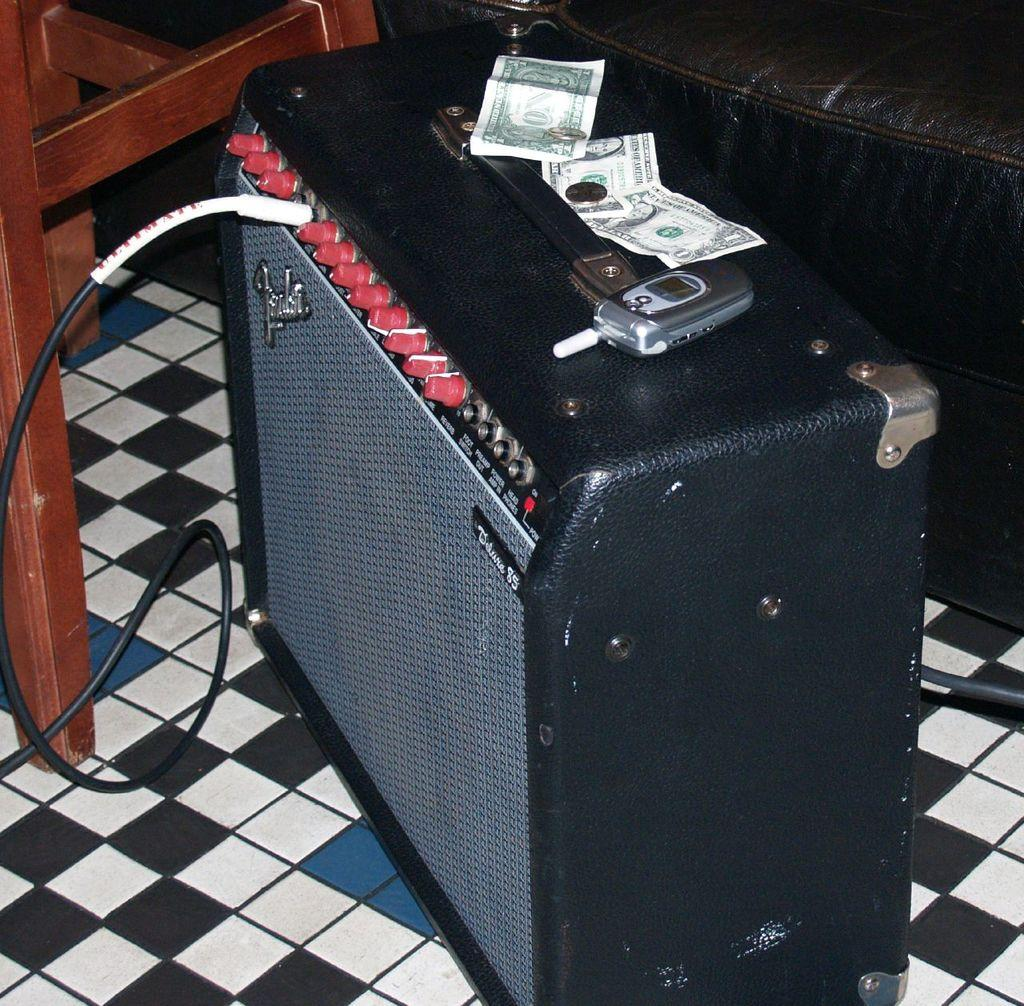What device is visible in the image? There is a speaker in the image. How is the speaker connected to another device? A cable is connected to the speaker. What is placed on top of the speaker? There is a mobile phone on the speaker. What type of currency is present on the speaker? Money notes are present on the speaker. What type of furniture is visible in the image? There is a chair and a couch in the image. What type of steel is used to construct the cave in the image? There is no cave present in the image, and therefore no steel construction can be observed. Where is the birth of the newborn baby taking place in the image? There is no newborn baby or birth scene present in the image. 